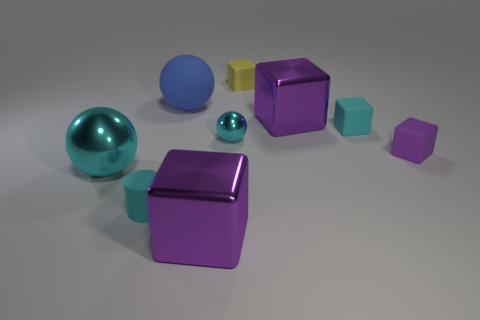Subtract all green spheres. How many purple blocks are left? 3 Subtract 2 blocks. How many blocks are left? 3 Subtract all blue cubes. Subtract all cyan cylinders. How many cubes are left? 5 Subtract all balls. How many objects are left? 6 Add 2 cyan blocks. How many cyan blocks are left? 3 Add 5 big rubber things. How many big rubber things exist? 6 Subtract 0 green cylinders. How many objects are left? 9 Subtract all big cyan spheres. Subtract all yellow cubes. How many objects are left? 7 